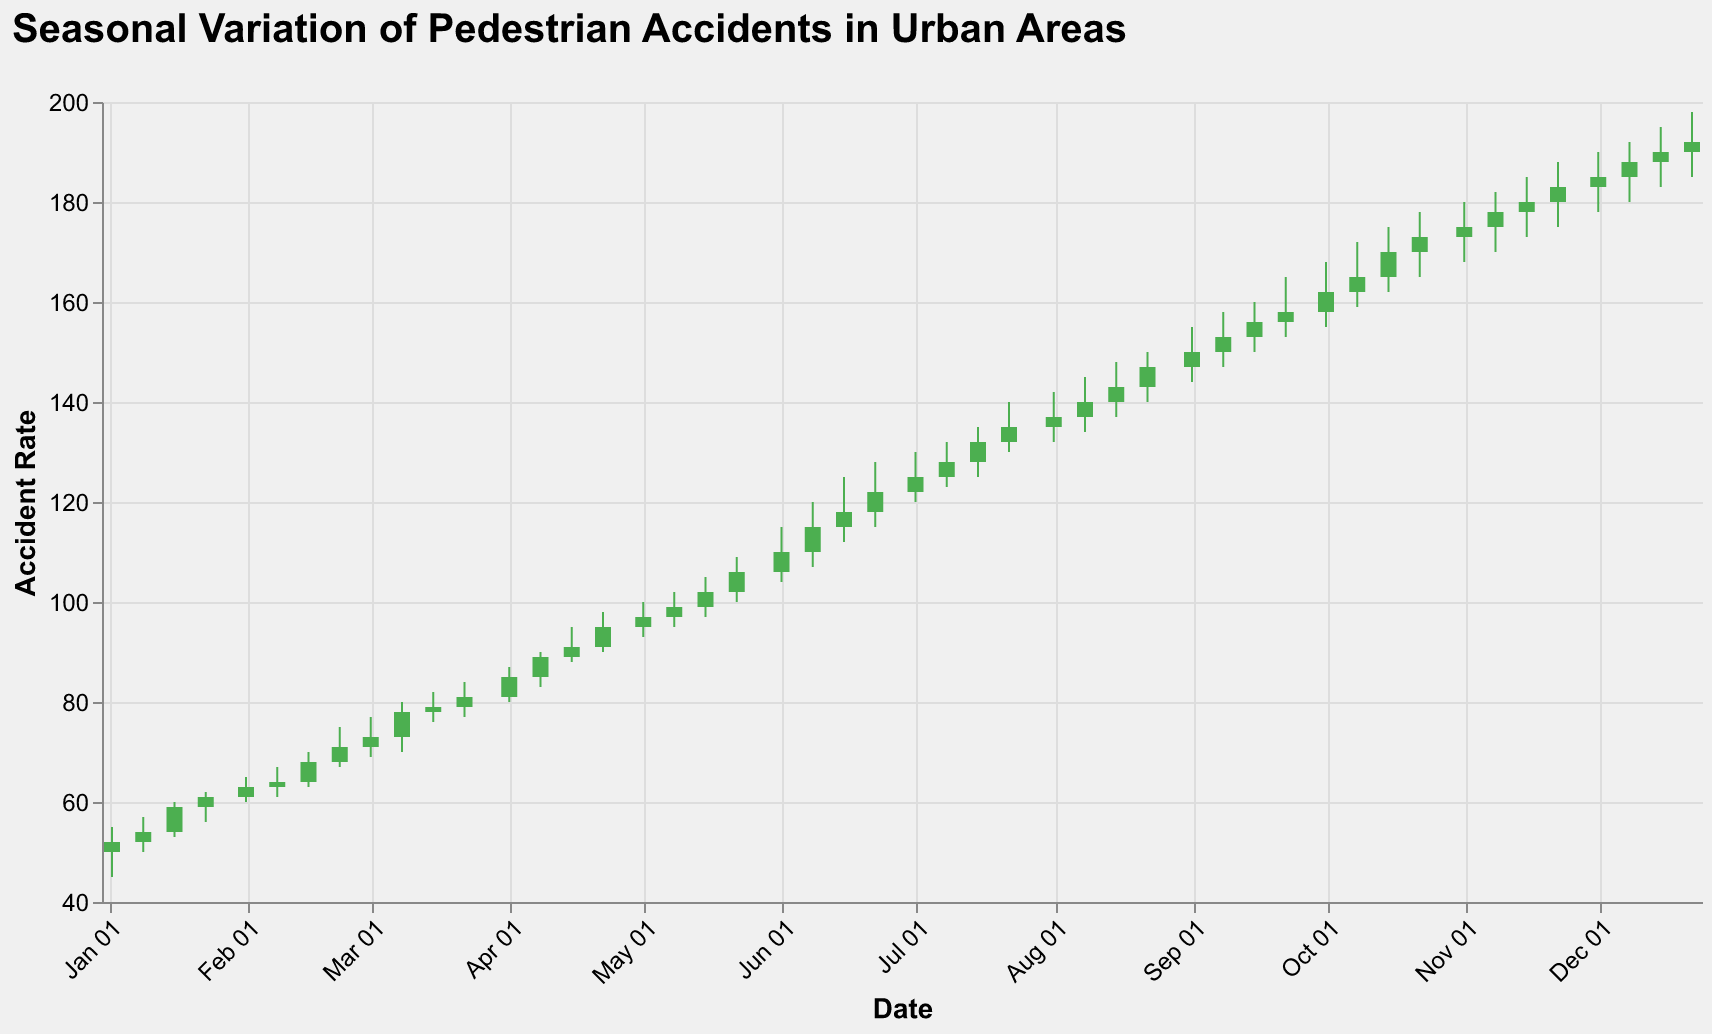What's the title of the figure? The title is displayed prominently at the top of the figure. It reads "Seasonal Variation of Pedestrian Accidents in Urban Areas."
Answer: Seasonal Variation of Pedestrian Accidents in Urban Areas What information is represented on the x-axis? The x-axis represents the dates, formatted as month and day (e.g., Jan 02). This can be observed from the date labels tilted at a -45-degree angle on the x-axis.
Answer: Date What color indicates an increase in the accident rate from open to close? The color green indicates an increase in the accident rate from open to close. This can be inferred from the color condition specified where 'datum.Open < datum.Close' determines the green color.
Answer: Green What is the high value on February 15, 2023? The high value on February 15, 2023, can be found by locating the corresponding candlestick for that date and checking the upper bound of the vertical line (or "wick") of the candlestick. It is 70.
Answer: 70 What's the difference between the high and low values on July 22, 2023? For July 22, 2023, the high value is 140 and the low value is 130. The difference is calculated as 140 - 130 = 10.
Answer: 10 During which month does the accident rate first exceed 150? By scanning through the candlestick plot, the accident rate first exceeds 150 in September 2023, as observed in the candlestick for September 1, 2023.
Answer: September 2023 What is the trend of the accident rate from January to December 2023? Observing the candlestick plot from January to December 2023, there is a clear upward trend in the accident rate, indicated by the increasing position of the candlesticks over time.
Answer: Upward trend Which period shows the greatest volatility in accident rates? Volatility can be inferred from the length of the wicks and the size of the bars. The greatest volatility appears between June and September 2023, where we notice larger candlesticks and significant variation in high and low values (e.g., from June 1 to September 22).
Answer: June to September 2023 What is the closing value on October 15, 2023? The closing value on October 15, 2023, is found at the top of the candlestick body, which is 170.
Answer: 170 